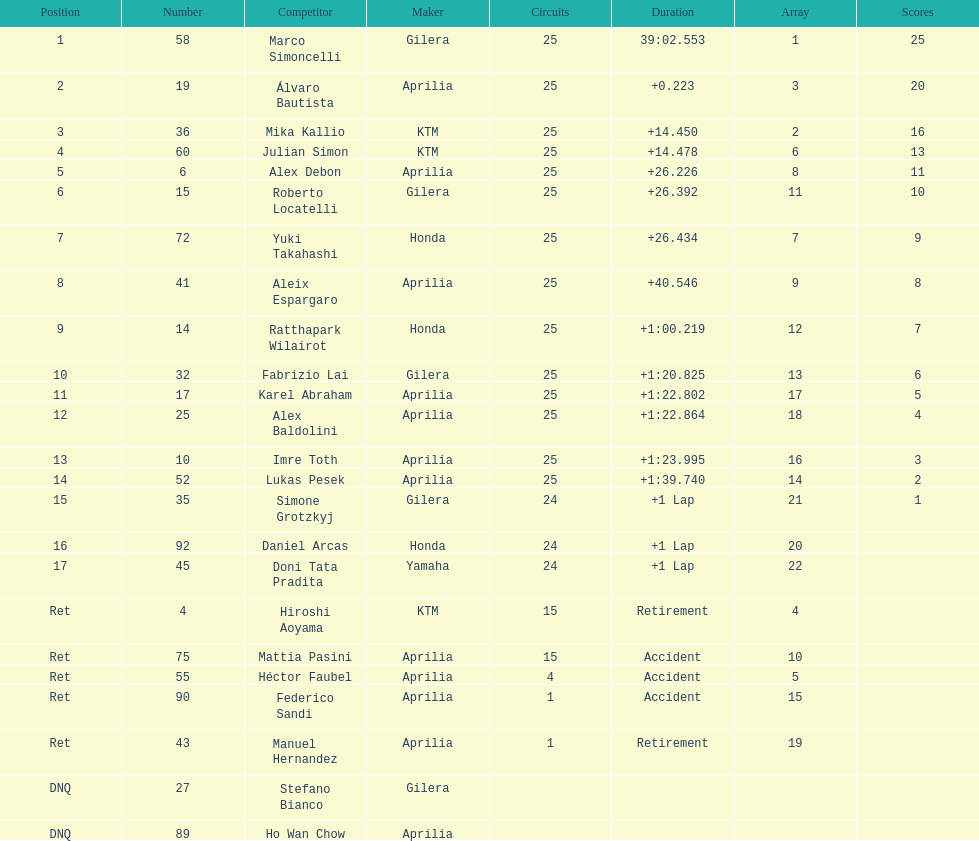What is the total number of laps performed by rider imre toth? 25. 